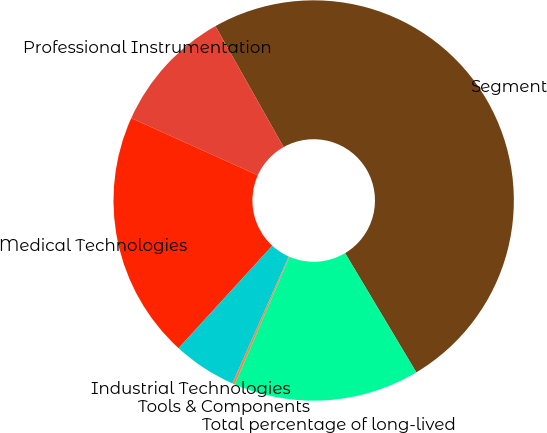Convert chart. <chart><loc_0><loc_0><loc_500><loc_500><pie_chart><fcel>Segment<fcel>Professional Instrumentation<fcel>Medical Technologies<fcel>Industrial Technologies<fcel>Tools & Components<fcel>Total percentage of long-lived<nl><fcel>49.6%<fcel>10.08%<fcel>19.96%<fcel>5.14%<fcel>0.2%<fcel>15.02%<nl></chart> 